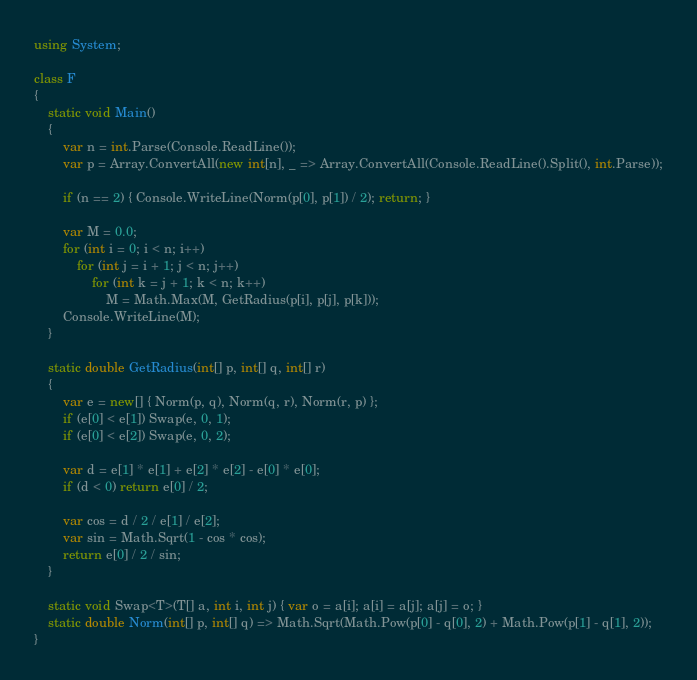<code> <loc_0><loc_0><loc_500><loc_500><_C#_>using System;

class F
{
	static void Main()
	{
		var n = int.Parse(Console.ReadLine());
		var p = Array.ConvertAll(new int[n], _ => Array.ConvertAll(Console.ReadLine().Split(), int.Parse));

		if (n == 2) { Console.WriteLine(Norm(p[0], p[1]) / 2); return; }

		var M = 0.0;
		for (int i = 0; i < n; i++)
			for (int j = i + 1; j < n; j++)
				for (int k = j + 1; k < n; k++)
					M = Math.Max(M, GetRadius(p[i], p[j], p[k]));
		Console.WriteLine(M);
	}

	static double GetRadius(int[] p, int[] q, int[] r)
	{
		var e = new[] { Norm(p, q), Norm(q, r), Norm(r, p) };
		if (e[0] < e[1]) Swap(e, 0, 1);
		if (e[0] < e[2]) Swap(e, 0, 2);

		var d = e[1] * e[1] + e[2] * e[2] - e[0] * e[0];
		if (d < 0) return e[0] / 2;

		var cos = d / 2 / e[1] / e[2];
		var sin = Math.Sqrt(1 - cos * cos);
		return e[0] / 2 / sin;
	}

	static void Swap<T>(T[] a, int i, int j) { var o = a[i]; a[i] = a[j]; a[j] = o; }
	static double Norm(int[] p, int[] q) => Math.Sqrt(Math.Pow(p[0] - q[0], 2) + Math.Pow(p[1] - q[1], 2));
}
</code> 